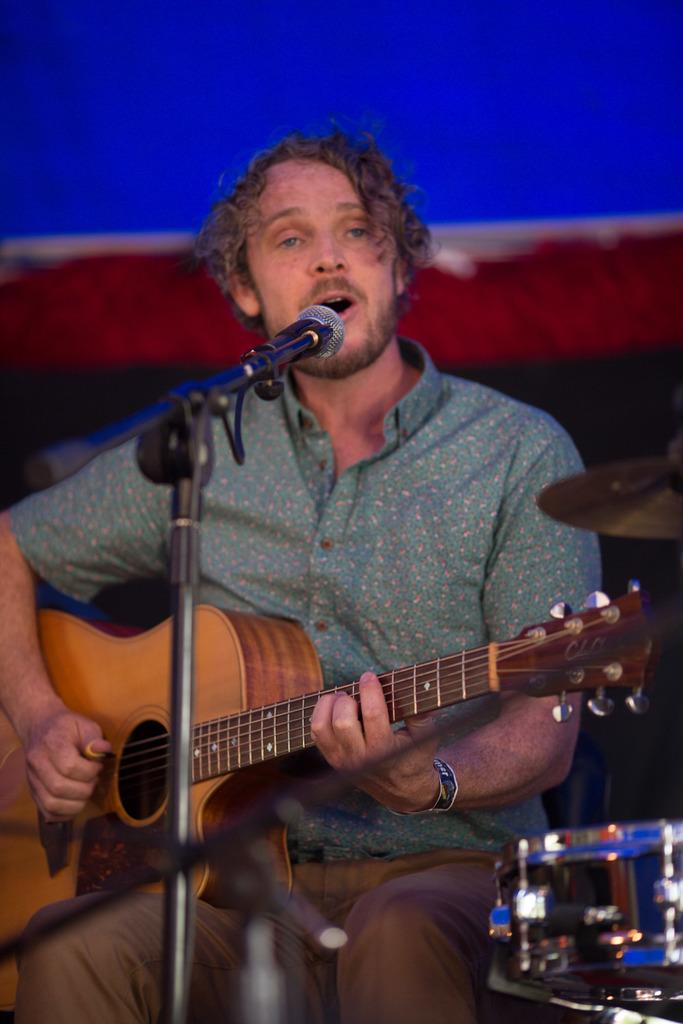What is the man in the image doing? The man is sitting and playing a guitar while singing into a microphone. What instrument can be seen in the bottom right side of the image? There is a drum in the bottom right side of the image. What type of protest is the man participating in with his heart and powder in the image? There is no protest, heart, or powder present in the image. The man is simply playing a guitar and singing into a microphone. 